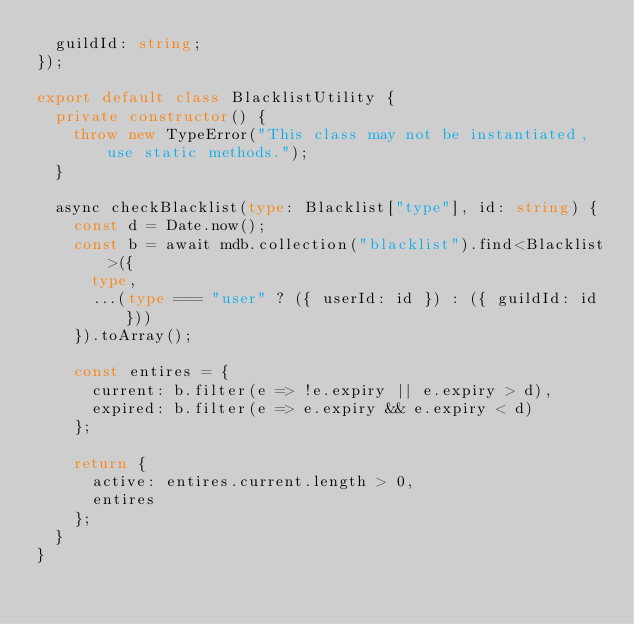Convert code to text. <code><loc_0><loc_0><loc_500><loc_500><_TypeScript_>	guildId: string;
});

export default class BlacklistUtility {
	private constructor() {
		throw new TypeError("This class may not be instantiated, use static methods.");
	}

	async checkBlacklist(type: Blacklist["type"], id: string) {
		const d = Date.now();
		const b = await mdb.collection("blacklist").find<Blacklist>({
			type,
			...(type === "user" ? ({ userId: id }) : ({ guildId: id }))
		}).toArray();

		const entires = {
			current: b.filter(e => !e.expiry || e.expiry > d),
			expired: b.filter(e => e.expiry && e.expiry < d)
		};

		return {
			active: entires.current.length > 0,
			entires
		};
	}
}
</code> 